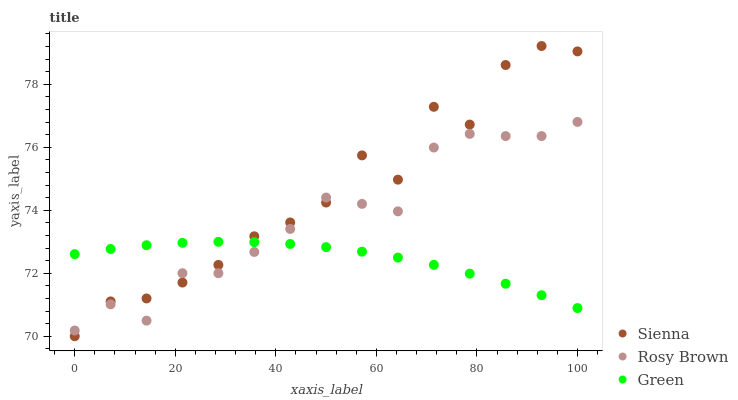Does Green have the minimum area under the curve?
Answer yes or no. Yes. Does Sienna have the maximum area under the curve?
Answer yes or no. Yes. Does Rosy Brown have the minimum area under the curve?
Answer yes or no. No. Does Rosy Brown have the maximum area under the curve?
Answer yes or no. No. Is Green the smoothest?
Answer yes or no. Yes. Is Sienna the roughest?
Answer yes or no. Yes. Is Rosy Brown the smoothest?
Answer yes or no. No. Is Rosy Brown the roughest?
Answer yes or no. No. Does Sienna have the lowest value?
Answer yes or no. Yes. Does Rosy Brown have the lowest value?
Answer yes or no. No. Does Sienna have the highest value?
Answer yes or no. Yes. Does Rosy Brown have the highest value?
Answer yes or no. No. Does Rosy Brown intersect Sienna?
Answer yes or no. Yes. Is Rosy Brown less than Sienna?
Answer yes or no. No. Is Rosy Brown greater than Sienna?
Answer yes or no. No. 